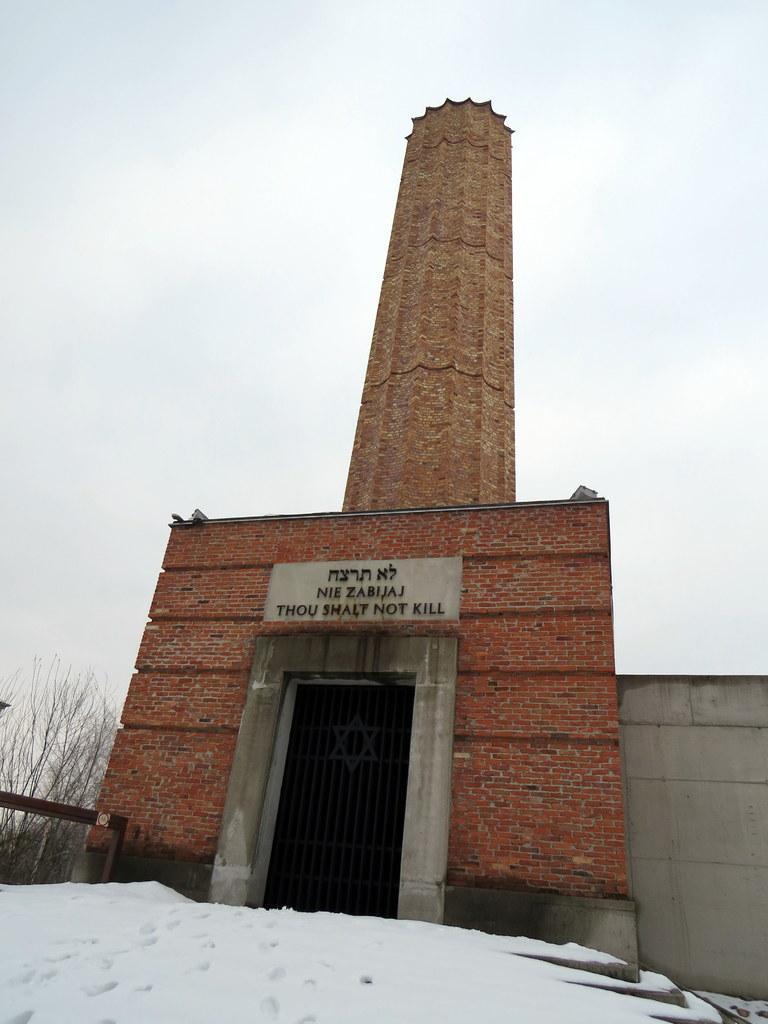Can you describe this image briefly? In this image I can see the snow which is white in color and a building which is brown in color. In the background I can see few trees and the sky. 